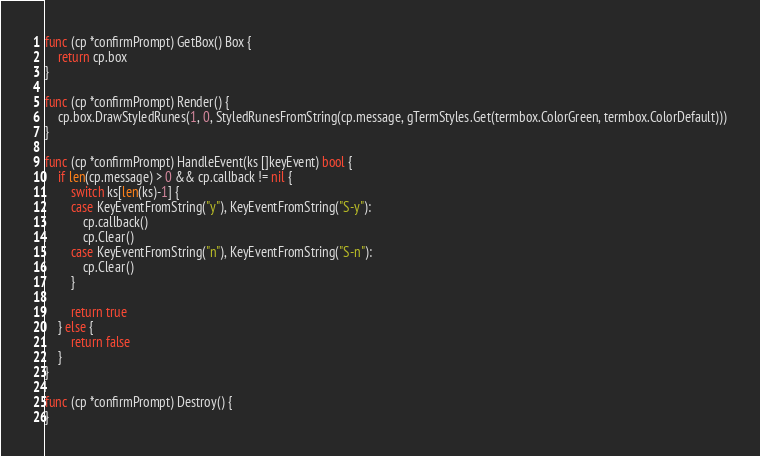<code> <loc_0><loc_0><loc_500><loc_500><_Go_>
func (cp *confirmPrompt) GetBox() Box {
	return cp.box
}

func (cp *confirmPrompt) Render() {
	cp.box.DrawStyledRunes(1, 0, StyledRunesFromString(cp.message, gTermStyles.Get(termbox.ColorGreen, termbox.ColorDefault)))
}

func (cp *confirmPrompt) HandleEvent(ks []keyEvent) bool {
	if len(cp.message) > 0 && cp.callback != nil {
		switch ks[len(ks)-1] {
		case KeyEventFromString("y"), KeyEventFromString("S-y"):
			cp.callback()
			cp.Clear()
		case KeyEventFromString("n"), KeyEventFromString("S-n"):
			cp.Clear()
		}

		return true
	} else {
		return false
	}
}

func (cp *confirmPrompt) Destroy() {
}
</code> 